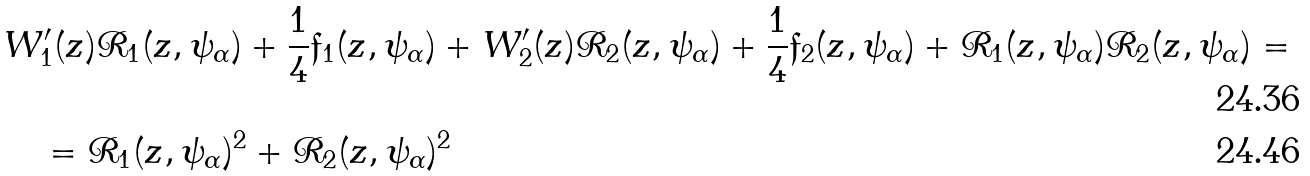<formula> <loc_0><loc_0><loc_500><loc_500>& W _ { 1 } ^ { \prime } ( z ) \mathcal { R } _ { 1 } ( z , \psi _ { \alpha } ) + \frac { 1 } { 4 } \mathfrak { f } _ { 1 } ( z , \psi _ { \alpha } ) + W _ { 2 } ^ { \prime } ( z ) \mathcal { R } _ { 2 } ( z , \psi _ { \alpha } ) + \frac { 1 } { 4 } \mathfrak { f } _ { 2 } ( z , \psi _ { \alpha } ) + \mathcal { R } _ { 1 } ( z , \psi _ { \alpha } ) \mathcal { R } _ { 2 } ( z , \psi _ { \alpha } ) = \\ & \quad = \mathcal { R } _ { 1 } ( z , \psi _ { \alpha } ) ^ { 2 } + \mathcal { R } _ { 2 } ( z , \psi _ { \alpha } ) ^ { 2 }</formula> 